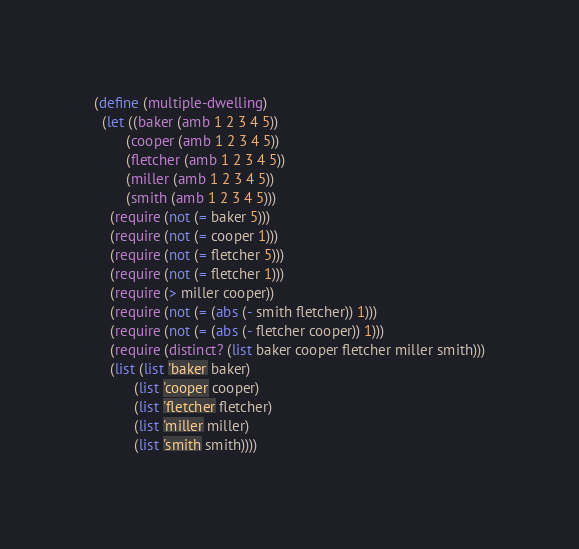<code> <loc_0><loc_0><loc_500><loc_500><_Scheme_>(define (multiple-dwelling)
  (let ((baker (amb 1 2 3 4 5))
        (cooper (amb 1 2 3 4 5))
        (fletcher (amb 1 2 3 4 5))
        (miller (amb 1 2 3 4 5))
        (smith (amb 1 2 3 4 5)))
    (require (not (= baker 5)))
    (require (not (= cooper 1)))
    (require (not (= fletcher 5)))
    (require (not (= fletcher 1)))
    (require (> miller cooper))
    (require (not (= (abs (- smith fletcher)) 1)))
    (require (not (= (abs (- fletcher cooper)) 1)))
    (require (distinct? (list baker cooper fletcher miller smith)))
    (list (list 'baker baker)
          (list 'cooper cooper)
          (list 'fletcher fletcher)
          (list 'miller miller)
          (list 'smith smith))))</code> 